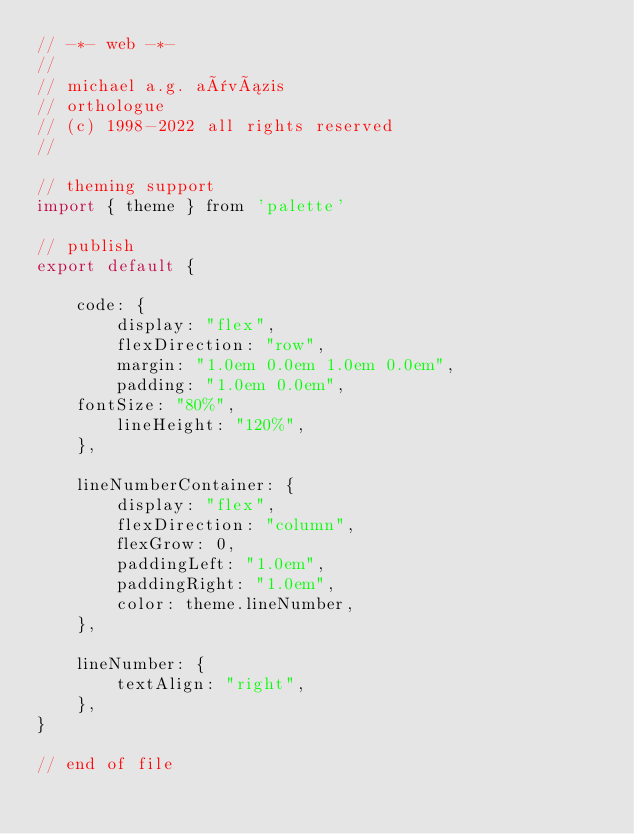Convert code to text. <code><loc_0><loc_0><loc_500><loc_500><_JavaScript_>// -*- web -*-
//
// michael a.g. aïvázis
// orthologue
// (c) 1998-2022 all rights reserved
//

// theming support
import { theme } from 'palette'

// publish
export default {

    code: {
        display: "flex",
        flexDirection: "row",
        margin: "1.0em 0.0em 1.0em 0.0em",
        padding: "1.0em 0.0em",
	fontSize: "80%",
        lineHeight: "120%",
    },

    lineNumberContainer: {
        display: "flex",
        flexDirection: "column",
        flexGrow: 0,
        paddingLeft: "1.0em",
        paddingRight: "1.0em",
        color: theme.lineNumber,
    },

    lineNumber: {
        textAlign: "right",
    },
}

// end of file
</code> 